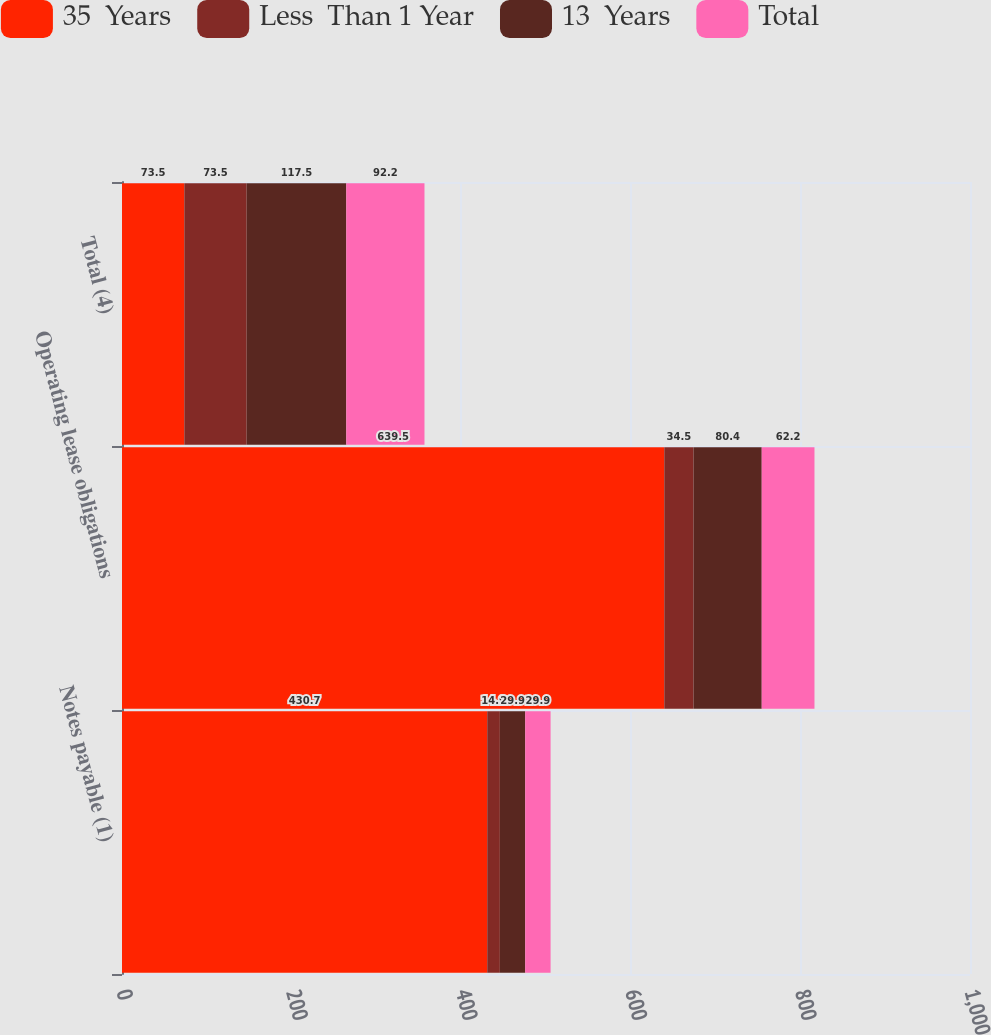Convert chart. <chart><loc_0><loc_0><loc_500><loc_500><stacked_bar_chart><ecel><fcel>Notes payable (1)<fcel>Operating lease obligations<fcel>Total (4)<nl><fcel>35  Years<fcel>430.7<fcel>639.5<fcel>73.5<nl><fcel>Less  Than 1 Year<fcel>14.9<fcel>34.5<fcel>73.5<nl><fcel>13  Years<fcel>29.9<fcel>80.4<fcel>117.5<nl><fcel>Total<fcel>29.9<fcel>62.2<fcel>92.2<nl></chart> 